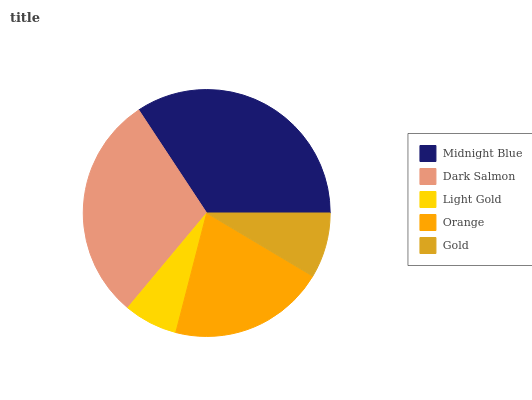Is Light Gold the minimum?
Answer yes or no. Yes. Is Midnight Blue the maximum?
Answer yes or no. Yes. Is Dark Salmon the minimum?
Answer yes or no. No. Is Dark Salmon the maximum?
Answer yes or no. No. Is Midnight Blue greater than Dark Salmon?
Answer yes or no. Yes. Is Dark Salmon less than Midnight Blue?
Answer yes or no. Yes. Is Dark Salmon greater than Midnight Blue?
Answer yes or no. No. Is Midnight Blue less than Dark Salmon?
Answer yes or no. No. Is Orange the high median?
Answer yes or no. Yes. Is Orange the low median?
Answer yes or no. Yes. Is Dark Salmon the high median?
Answer yes or no. No. Is Dark Salmon the low median?
Answer yes or no. No. 